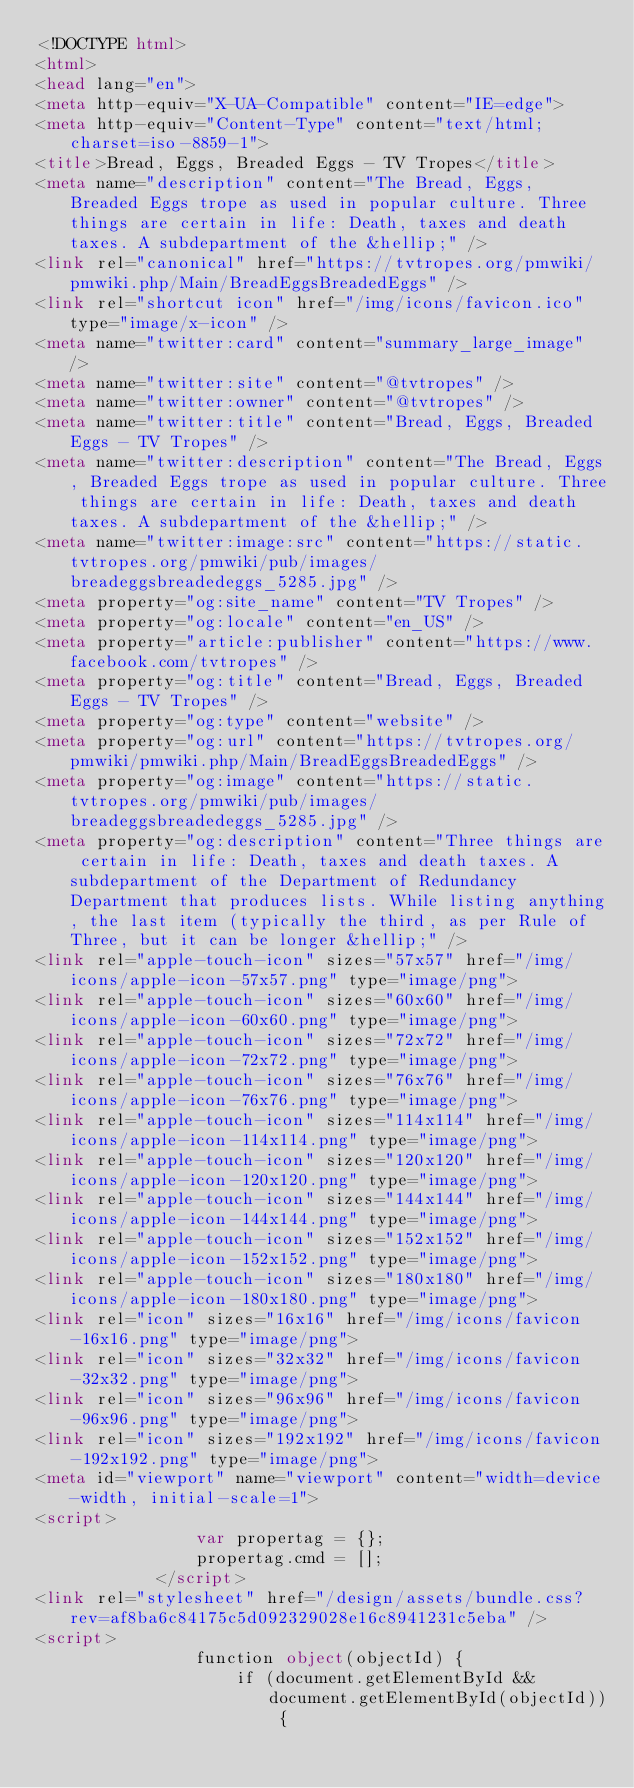<code> <loc_0><loc_0><loc_500><loc_500><_HTML_><!DOCTYPE html>
<html>
<head lang="en">
<meta http-equiv="X-UA-Compatible" content="IE=edge">
<meta http-equiv="Content-Type" content="text/html; charset=iso-8859-1">
<title>Bread, Eggs, Breaded Eggs - TV Tropes</title>
<meta name="description" content="The Bread, Eggs, Breaded Eggs trope as used in popular culture. Three things are certain in life: Death, taxes and death taxes. A subdepartment of the &hellip;" />
<link rel="canonical" href="https://tvtropes.org/pmwiki/pmwiki.php/Main/BreadEggsBreadedEggs" />
<link rel="shortcut icon" href="/img/icons/favicon.ico" type="image/x-icon" />
<meta name="twitter:card" content="summary_large_image" />
<meta name="twitter:site" content="@tvtropes" />
<meta name="twitter:owner" content="@tvtropes" />
<meta name="twitter:title" content="Bread, Eggs, Breaded Eggs - TV Tropes" />
<meta name="twitter:description" content="The Bread, Eggs, Breaded Eggs trope as used in popular culture. Three things are certain in life: Death, taxes and death taxes. A subdepartment of the &hellip;" />
<meta name="twitter:image:src" content="https://static.tvtropes.org/pmwiki/pub/images/breadeggsbreadedeggs_5285.jpg" />
<meta property="og:site_name" content="TV Tropes" />
<meta property="og:locale" content="en_US" />
<meta property="article:publisher" content="https://www.facebook.com/tvtropes" />
<meta property="og:title" content="Bread, Eggs, Breaded Eggs - TV Tropes" />
<meta property="og:type" content="website" />
<meta property="og:url" content="https://tvtropes.org/pmwiki/pmwiki.php/Main/BreadEggsBreadedEggs" />
<meta property="og:image" content="https://static.tvtropes.org/pmwiki/pub/images/breadeggsbreadedeggs_5285.jpg" />
<meta property="og:description" content="Three things are certain in life: Death, taxes and death taxes. A subdepartment of the Department of Redundancy Department that produces lists. While listing anything, the last item (typically the third, as per Rule of Three, but it can be longer &hellip;" />
<link rel="apple-touch-icon" sizes="57x57" href="/img/icons/apple-icon-57x57.png" type="image/png">
<link rel="apple-touch-icon" sizes="60x60" href="/img/icons/apple-icon-60x60.png" type="image/png">
<link rel="apple-touch-icon" sizes="72x72" href="/img/icons/apple-icon-72x72.png" type="image/png">
<link rel="apple-touch-icon" sizes="76x76" href="/img/icons/apple-icon-76x76.png" type="image/png">
<link rel="apple-touch-icon" sizes="114x114" href="/img/icons/apple-icon-114x114.png" type="image/png">
<link rel="apple-touch-icon" sizes="120x120" href="/img/icons/apple-icon-120x120.png" type="image/png">
<link rel="apple-touch-icon" sizes="144x144" href="/img/icons/apple-icon-144x144.png" type="image/png">
<link rel="apple-touch-icon" sizes="152x152" href="/img/icons/apple-icon-152x152.png" type="image/png">
<link rel="apple-touch-icon" sizes="180x180" href="/img/icons/apple-icon-180x180.png" type="image/png">
<link rel="icon" sizes="16x16" href="/img/icons/favicon-16x16.png" type="image/png">
<link rel="icon" sizes="32x32" href="/img/icons/favicon-32x32.png" type="image/png">
<link rel="icon" sizes="96x96" href="/img/icons/favicon-96x96.png" type="image/png">
<link rel="icon" sizes="192x192" href="/img/icons/favicon-192x192.png" type="image/png">
<meta id="viewport" name="viewport" content="width=device-width, initial-scale=1">
<script>
                var propertag = {};
                propertag.cmd = [];
            </script>
<link rel="stylesheet" href="/design/assets/bundle.css?rev=af8ba6c84175c5d092329028e16c8941231c5eba" />
<script>
                function object(objectId) {
                    if (document.getElementById && document.getElementById(objectId)) {</code> 